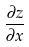Convert formula to latex. <formula><loc_0><loc_0><loc_500><loc_500>\frac { \partial z } { \partial x }</formula> 